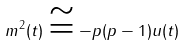Convert formula to latex. <formula><loc_0><loc_0><loc_500><loc_500>m ^ { 2 } ( t ) \cong - p ( p - 1 ) u ( t )</formula> 